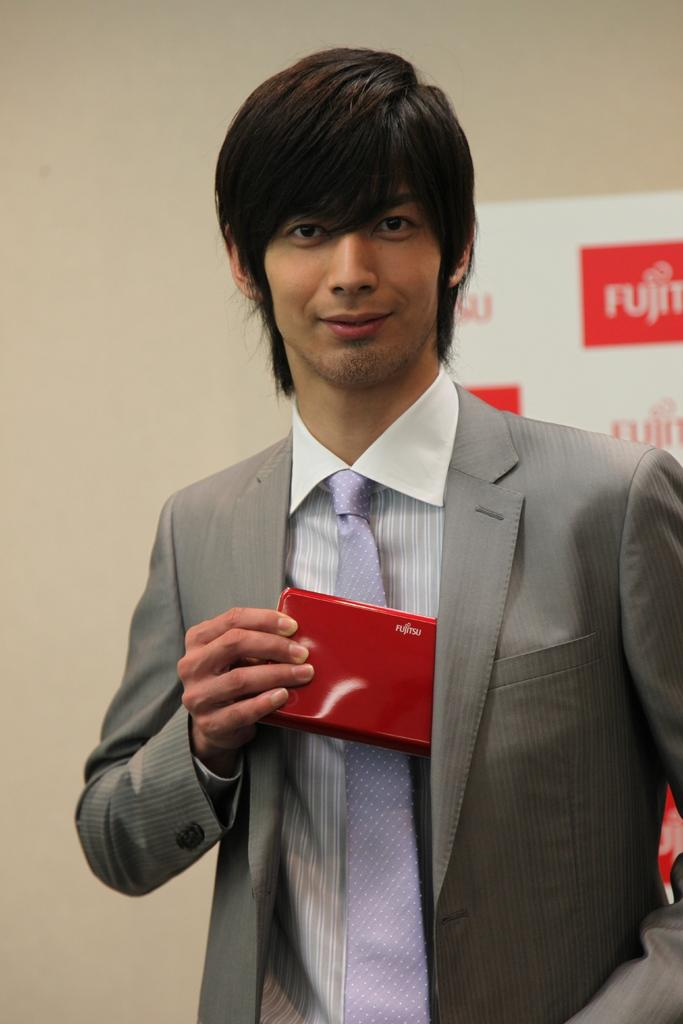What is the man in the image doing? The man is standing in the image. What is the man holding in the image? The man is holding an item. What can be seen in the background of the image? There is a board and a wall visible in the background of the image. How many jellyfish are swimming in the background of the image? There are no jellyfish present in the image; the background features a board and a wall. 